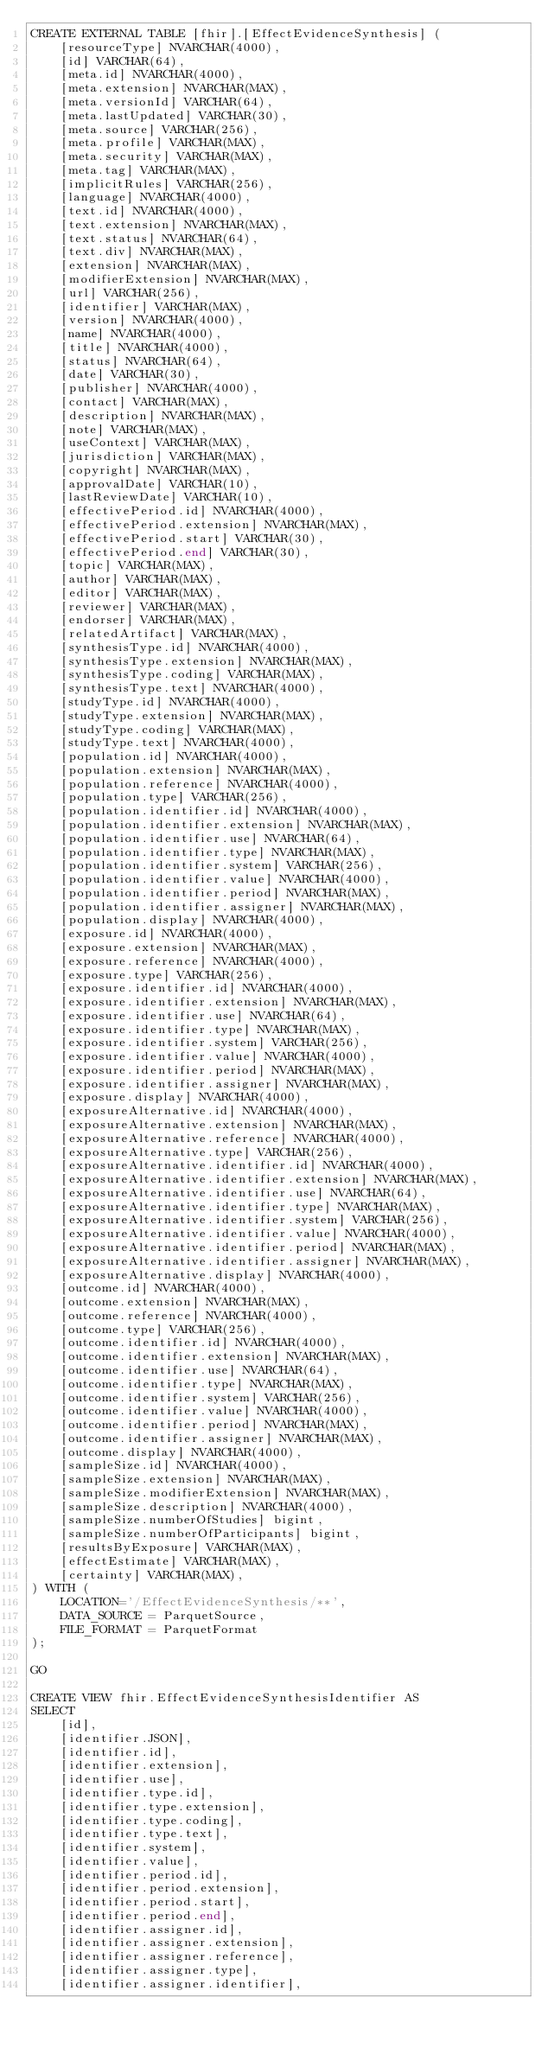<code> <loc_0><loc_0><loc_500><loc_500><_SQL_>CREATE EXTERNAL TABLE [fhir].[EffectEvidenceSynthesis] (
    [resourceType] NVARCHAR(4000),
    [id] VARCHAR(64),
    [meta.id] NVARCHAR(4000),
    [meta.extension] NVARCHAR(MAX),
    [meta.versionId] VARCHAR(64),
    [meta.lastUpdated] VARCHAR(30),
    [meta.source] VARCHAR(256),
    [meta.profile] VARCHAR(MAX),
    [meta.security] VARCHAR(MAX),
    [meta.tag] VARCHAR(MAX),
    [implicitRules] VARCHAR(256),
    [language] NVARCHAR(4000),
    [text.id] NVARCHAR(4000),
    [text.extension] NVARCHAR(MAX),
    [text.status] NVARCHAR(64),
    [text.div] NVARCHAR(MAX),
    [extension] NVARCHAR(MAX),
    [modifierExtension] NVARCHAR(MAX),
    [url] VARCHAR(256),
    [identifier] VARCHAR(MAX),
    [version] NVARCHAR(4000),
    [name] NVARCHAR(4000),
    [title] NVARCHAR(4000),
    [status] NVARCHAR(64),
    [date] VARCHAR(30),
    [publisher] NVARCHAR(4000),
    [contact] VARCHAR(MAX),
    [description] NVARCHAR(MAX),
    [note] VARCHAR(MAX),
    [useContext] VARCHAR(MAX),
    [jurisdiction] VARCHAR(MAX),
    [copyright] NVARCHAR(MAX),
    [approvalDate] VARCHAR(10),
    [lastReviewDate] VARCHAR(10),
    [effectivePeriod.id] NVARCHAR(4000),
    [effectivePeriod.extension] NVARCHAR(MAX),
    [effectivePeriod.start] VARCHAR(30),
    [effectivePeriod.end] VARCHAR(30),
    [topic] VARCHAR(MAX),
    [author] VARCHAR(MAX),
    [editor] VARCHAR(MAX),
    [reviewer] VARCHAR(MAX),
    [endorser] VARCHAR(MAX),
    [relatedArtifact] VARCHAR(MAX),
    [synthesisType.id] NVARCHAR(4000),
    [synthesisType.extension] NVARCHAR(MAX),
    [synthesisType.coding] VARCHAR(MAX),
    [synthesisType.text] NVARCHAR(4000),
    [studyType.id] NVARCHAR(4000),
    [studyType.extension] NVARCHAR(MAX),
    [studyType.coding] VARCHAR(MAX),
    [studyType.text] NVARCHAR(4000),
    [population.id] NVARCHAR(4000),
    [population.extension] NVARCHAR(MAX),
    [population.reference] NVARCHAR(4000),
    [population.type] VARCHAR(256),
    [population.identifier.id] NVARCHAR(4000),
    [population.identifier.extension] NVARCHAR(MAX),
    [population.identifier.use] NVARCHAR(64),
    [population.identifier.type] NVARCHAR(MAX),
    [population.identifier.system] VARCHAR(256),
    [population.identifier.value] NVARCHAR(4000),
    [population.identifier.period] NVARCHAR(MAX),
    [population.identifier.assigner] NVARCHAR(MAX),
    [population.display] NVARCHAR(4000),
    [exposure.id] NVARCHAR(4000),
    [exposure.extension] NVARCHAR(MAX),
    [exposure.reference] NVARCHAR(4000),
    [exposure.type] VARCHAR(256),
    [exposure.identifier.id] NVARCHAR(4000),
    [exposure.identifier.extension] NVARCHAR(MAX),
    [exposure.identifier.use] NVARCHAR(64),
    [exposure.identifier.type] NVARCHAR(MAX),
    [exposure.identifier.system] VARCHAR(256),
    [exposure.identifier.value] NVARCHAR(4000),
    [exposure.identifier.period] NVARCHAR(MAX),
    [exposure.identifier.assigner] NVARCHAR(MAX),
    [exposure.display] NVARCHAR(4000),
    [exposureAlternative.id] NVARCHAR(4000),
    [exposureAlternative.extension] NVARCHAR(MAX),
    [exposureAlternative.reference] NVARCHAR(4000),
    [exposureAlternative.type] VARCHAR(256),
    [exposureAlternative.identifier.id] NVARCHAR(4000),
    [exposureAlternative.identifier.extension] NVARCHAR(MAX),
    [exposureAlternative.identifier.use] NVARCHAR(64),
    [exposureAlternative.identifier.type] NVARCHAR(MAX),
    [exposureAlternative.identifier.system] VARCHAR(256),
    [exposureAlternative.identifier.value] NVARCHAR(4000),
    [exposureAlternative.identifier.period] NVARCHAR(MAX),
    [exposureAlternative.identifier.assigner] NVARCHAR(MAX),
    [exposureAlternative.display] NVARCHAR(4000),
    [outcome.id] NVARCHAR(4000),
    [outcome.extension] NVARCHAR(MAX),
    [outcome.reference] NVARCHAR(4000),
    [outcome.type] VARCHAR(256),
    [outcome.identifier.id] NVARCHAR(4000),
    [outcome.identifier.extension] NVARCHAR(MAX),
    [outcome.identifier.use] NVARCHAR(64),
    [outcome.identifier.type] NVARCHAR(MAX),
    [outcome.identifier.system] VARCHAR(256),
    [outcome.identifier.value] NVARCHAR(4000),
    [outcome.identifier.period] NVARCHAR(MAX),
    [outcome.identifier.assigner] NVARCHAR(MAX),
    [outcome.display] NVARCHAR(4000),
    [sampleSize.id] NVARCHAR(4000),
    [sampleSize.extension] NVARCHAR(MAX),
    [sampleSize.modifierExtension] NVARCHAR(MAX),
    [sampleSize.description] NVARCHAR(4000),
    [sampleSize.numberOfStudies] bigint,
    [sampleSize.numberOfParticipants] bigint,
    [resultsByExposure] VARCHAR(MAX),
    [effectEstimate] VARCHAR(MAX),
    [certainty] VARCHAR(MAX),
) WITH (
    LOCATION='/EffectEvidenceSynthesis/**',
    DATA_SOURCE = ParquetSource,
    FILE_FORMAT = ParquetFormat
);

GO

CREATE VIEW fhir.EffectEvidenceSynthesisIdentifier AS
SELECT
    [id],
    [identifier.JSON],
    [identifier.id],
    [identifier.extension],
    [identifier.use],
    [identifier.type.id],
    [identifier.type.extension],
    [identifier.type.coding],
    [identifier.type.text],
    [identifier.system],
    [identifier.value],
    [identifier.period.id],
    [identifier.period.extension],
    [identifier.period.start],
    [identifier.period.end],
    [identifier.assigner.id],
    [identifier.assigner.extension],
    [identifier.assigner.reference],
    [identifier.assigner.type],
    [identifier.assigner.identifier],</code> 